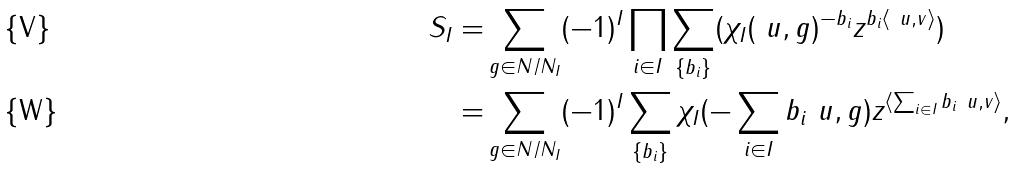Convert formula to latex. <formula><loc_0><loc_0><loc_500><loc_500>S _ { I } = & \sum _ { g \in N / N _ { I } } ( - 1 ) ^ { I } \prod _ { i \in I } \sum _ { \{ b _ { i } \} } ( \chi _ { I } ( \ u , g ) ^ { - b _ { i } } z ^ { b _ { i } \langle \ u , v \rangle } ) \\ = & \sum _ { g \in N / N _ { I } } ( - 1 ) ^ { I } \sum _ { \{ b _ { i } \} } \chi _ { I } ( - \sum _ { i \in I } b _ { i } \ u , g ) z ^ { \langle \sum _ { i \in I } b _ { i } \ u , v \rangle } ,</formula> 